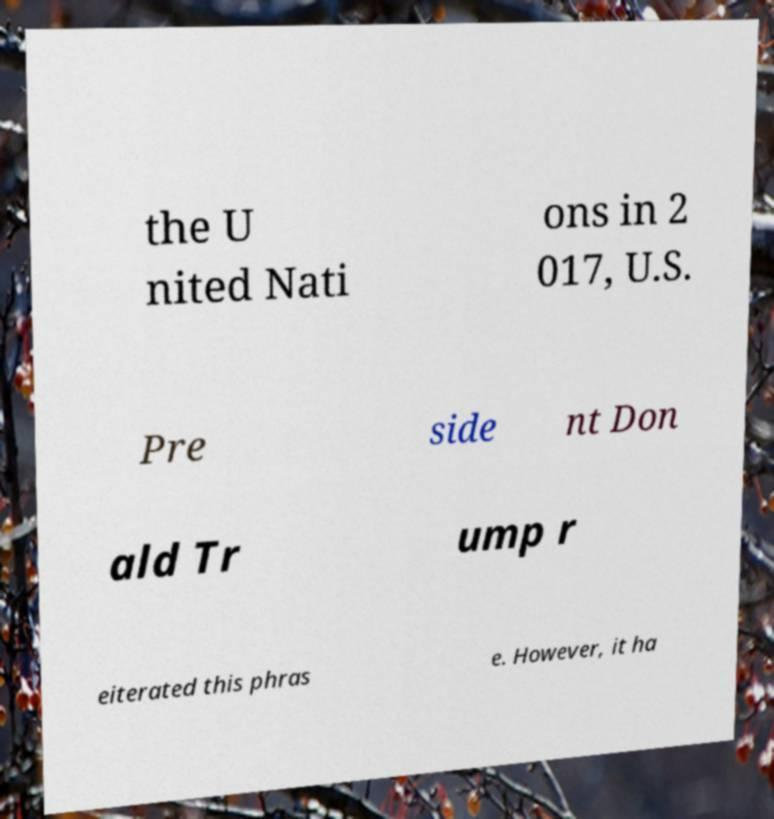Please identify and transcribe the text found in this image. the U nited Nati ons in 2 017, U.S. Pre side nt Don ald Tr ump r eiterated this phras e. However, it ha 